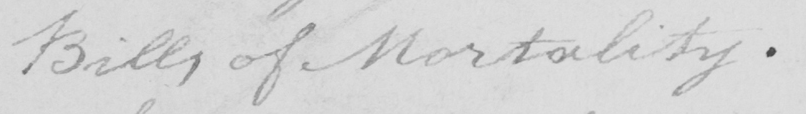Can you tell me what this handwritten text says? Bills of Mortablity . 